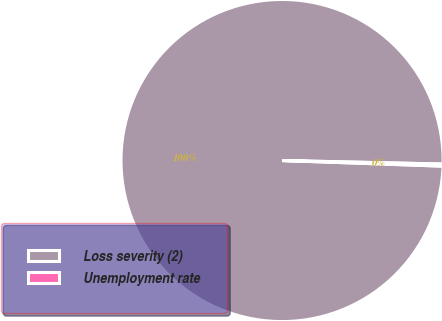<chart> <loc_0><loc_0><loc_500><loc_500><pie_chart><fcel>Loss severity (2)<fcel>Unemployment rate<nl><fcel>99.79%<fcel>0.21%<nl></chart> 